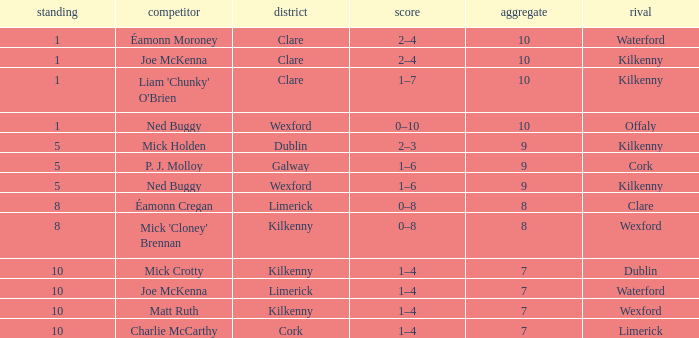What is galway county's total? 9.0. 